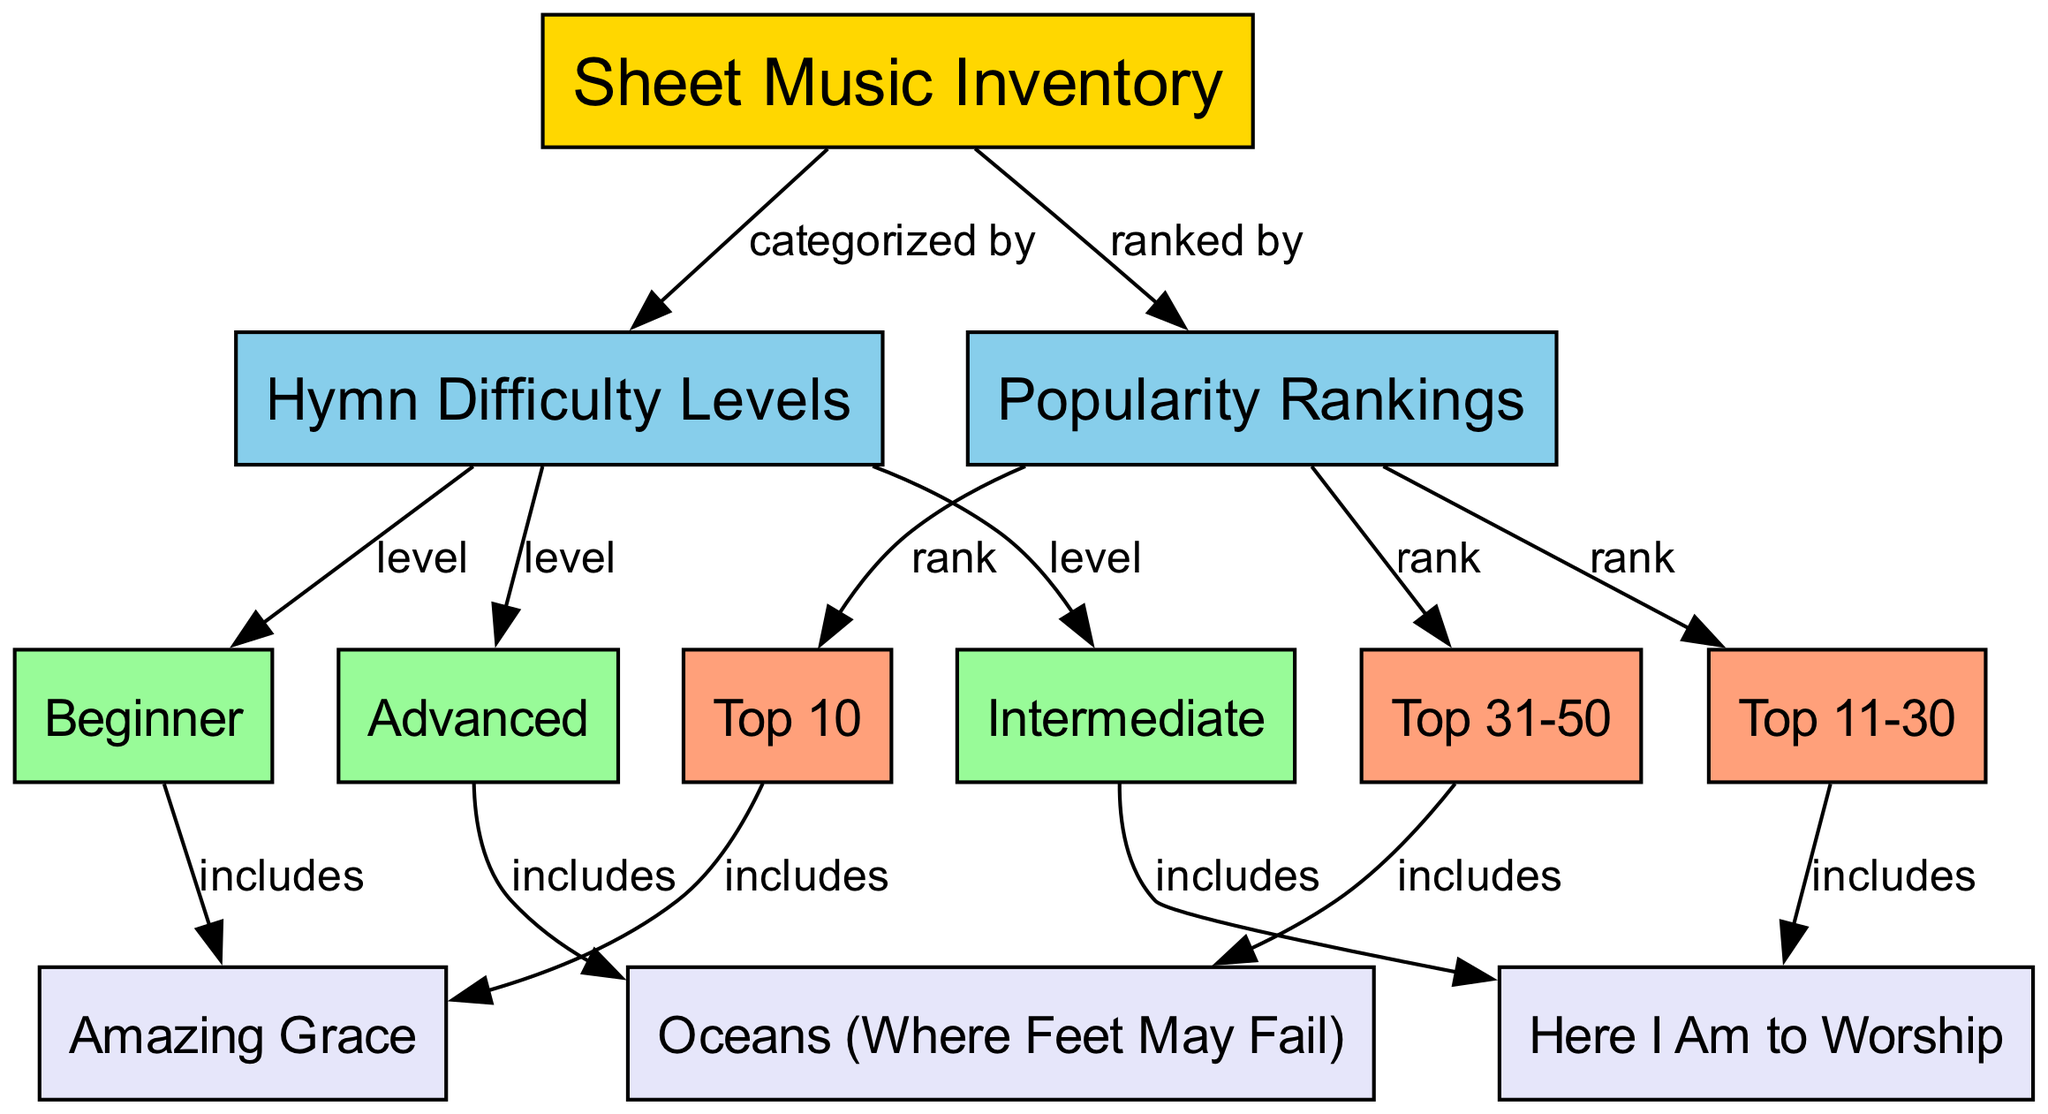What is the main focus of the diagram? The main focus of the diagram is the "Sheet Music Inventory," which is indicated as the root node. This node is at the top of the diagram and serves as the central theme, categorizing hymns by difficulty levels and popularity rankings.
Answer: Sheet Music Inventory How many hymn difficulty levels are represented in the diagram? The diagram shows three hymn difficulty levels: Beginner, Intermediate, and Advanced. These are directly connected to the "Hymn Difficulty Levels" node, indicating all levels present.
Answer: 3 Which hymn is categorized as Advanced? The Advanced category includes the hymn "Oceans (Where Feet May Fail)," which is the sole hymn listed under the Advanced node in the diagram.
Answer: Oceans (Where Feet May Fail) What hymns are included in the Top 10 popularity ranking? The Top 10 popularity ranking includes the hymn "Amazing Grace," as noted by the connection between the Top 10 node and its corresponding hymn.
Answer: Amazing Grace Which hymn falls under the Intermediate difficulty level? The Intermediate category includes "Here I Am to Worship," shown by the connection from the Intermediate node to this particular hymn node.
Answer: Here I Am to Worship Which category contains the most hymns? The "Top 11-30" category contains one hymn, which is "Here I Am to Worship." Comparatively, the other categories either contain one or no hymns.
Answer: Top 11-30 How are the hymns ranked in terms of popularity? The hymns are ranked by three categories: Top 10, Top 11-30, and Top 31-50, which differentiate their popularity levels based on the connections illustrated in the diagram.
Answer: Top 10, Top 11-30, Top 31-50 What is the relationship between the Sheet Music Inventory and the Hymn Difficulty Levels? The relationship is established by the edge indicating "categorized by," showing how the sheet music inventory segments hymns into different difficulty levels.
Answer: categorized by Which level contains the hymn “Amazing Grace”? The hymn “Amazing Grace” is included in the Beginner difficulty level, as demonstrated by the connection between the Beginner node and the hymn.
Answer: Beginner 